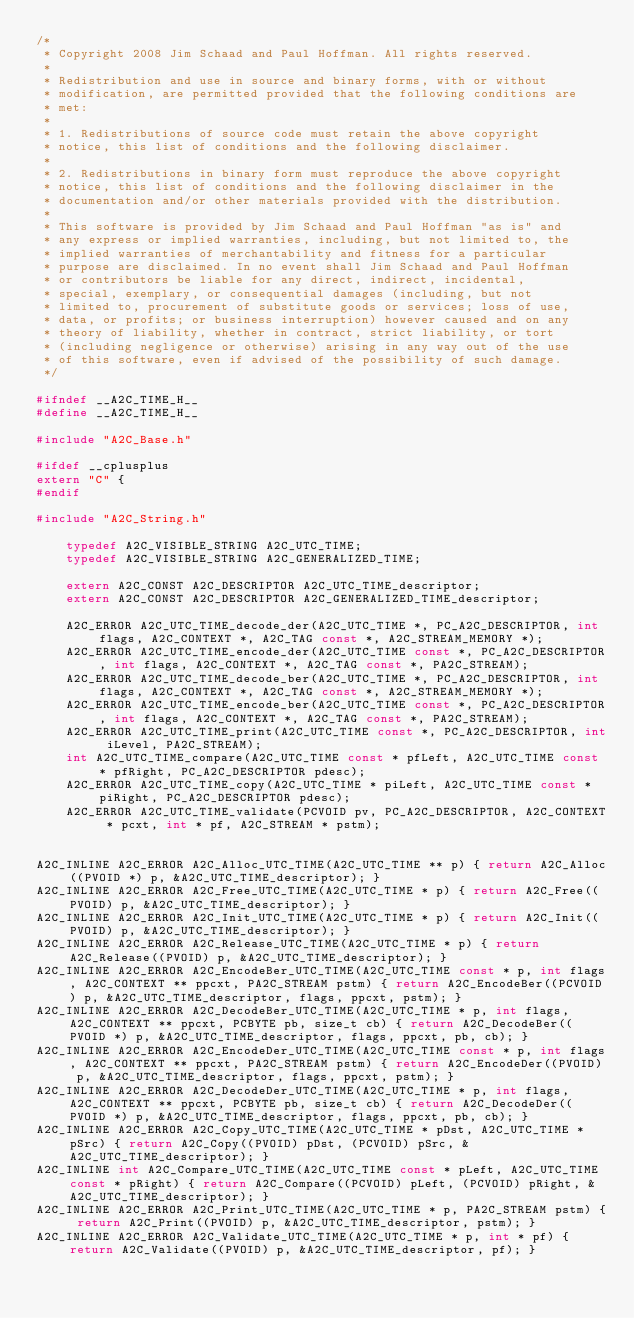<code> <loc_0><loc_0><loc_500><loc_500><_C_>/* 
 * Copyright 2008 Jim Schaad and Paul Hoffman. All rights reserved.
 * 
 * Redistribution and use in source and binary forms, with or without
 * modification, are permitted provided that the following conditions are
 * met:
 * 
 * 1. Redistributions of source code must retain the above copyright
 * notice, this list of conditions and the following disclaimer.
 * 
 * 2. Redistributions in binary form must reproduce the above copyright
 * notice, this list of conditions and the following disclaimer in the
 * documentation and/or other materials provided with the distribution.
 * 
 * This software is provided by Jim Schaad and Paul Hoffman "as is" and
 * any express or implied warranties, including, but not limited to, the
 * implied warranties of merchantability and fitness for a particular
 * purpose are disclaimed. In no event shall Jim Schaad and Paul Hoffman
 * or contributors be liable for any direct, indirect, incidental,
 * special, exemplary, or consequential damages (including, but not
 * limited to, procurement of substitute goods or services; loss of use,
 * data, or profits; or business interruption) however caused and on any
 * theory of liability, whether in contract, strict liability, or tort
 * (including negligence or otherwise) arising in any way out of the use
 * of this software, even if advised of the possibility of such damage.
 */

#ifndef __A2C_TIME_H__
#define __A2C_TIME_H__

#include "A2C_Base.h"

#ifdef __cplusplus
extern "C" {
#endif

#include "A2C_String.h"
    
    typedef A2C_VISIBLE_STRING A2C_UTC_TIME;
    typedef A2C_VISIBLE_STRING A2C_GENERALIZED_TIME;

    extern A2C_CONST A2C_DESCRIPTOR A2C_UTC_TIME_descriptor;
    extern A2C_CONST A2C_DESCRIPTOR A2C_GENERALIZED_TIME_descriptor;

    A2C_ERROR A2C_UTC_TIME_decode_der(A2C_UTC_TIME *, PC_A2C_DESCRIPTOR, int flags, A2C_CONTEXT *, A2C_TAG const *, A2C_STREAM_MEMORY *);
    A2C_ERROR A2C_UTC_TIME_encode_der(A2C_UTC_TIME const *, PC_A2C_DESCRIPTOR, int flags, A2C_CONTEXT *, A2C_TAG const *, PA2C_STREAM);
    A2C_ERROR A2C_UTC_TIME_decode_ber(A2C_UTC_TIME *, PC_A2C_DESCRIPTOR, int flags, A2C_CONTEXT *, A2C_TAG const *, A2C_STREAM_MEMORY *);
    A2C_ERROR A2C_UTC_TIME_encode_ber(A2C_UTC_TIME const *, PC_A2C_DESCRIPTOR, int flags, A2C_CONTEXT *, A2C_TAG const *, PA2C_STREAM);
    A2C_ERROR A2C_UTC_TIME_print(A2C_UTC_TIME const *, PC_A2C_DESCRIPTOR, int iLevel, PA2C_STREAM);
    int A2C_UTC_TIME_compare(A2C_UTC_TIME const * pfLeft, A2C_UTC_TIME const * pfRight, PC_A2C_DESCRIPTOR pdesc);
    A2C_ERROR A2C_UTC_TIME_copy(A2C_UTC_TIME * piLeft, A2C_UTC_TIME const * piRight, PC_A2C_DESCRIPTOR pdesc);
    A2C_ERROR A2C_UTC_TIME_validate(PCVOID pv, PC_A2C_DESCRIPTOR, A2C_CONTEXT * pcxt, int * pf, A2C_STREAM * pstm);


A2C_INLINE A2C_ERROR A2C_Alloc_UTC_TIME(A2C_UTC_TIME ** p) { return A2C_Alloc((PVOID *) p, &A2C_UTC_TIME_descriptor); } 
A2C_INLINE A2C_ERROR A2C_Free_UTC_TIME(A2C_UTC_TIME * p) { return A2C_Free((PVOID) p, &A2C_UTC_TIME_descriptor); } 
A2C_INLINE A2C_ERROR A2C_Init_UTC_TIME(A2C_UTC_TIME * p) { return A2C_Init((PVOID) p, &A2C_UTC_TIME_descriptor); } 
A2C_INLINE A2C_ERROR A2C_Release_UTC_TIME(A2C_UTC_TIME * p) { return A2C_Release((PVOID) p, &A2C_UTC_TIME_descriptor); } 
A2C_INLINE A2C_ERROR A2C_EncodeBer_UTC_TIME(A2C_UTC_TIME const * p, int flags, A2C_CONTEXT ** ppcxt, PA2C_STREAM pstm) { return A2C_EncodeBer((PCVOID) p, &A2C_UTC_TIME_descriptor, flags, ppcxt, pstm); } 
A2C_INLINE A2C_ERROR A2C_DecodeBer_UTC_TIME(A2C_UTC_TIME * p, int flags, A2C_CONTEXT ** ppcxt, PCBYTE pb, size_t cb) { return A2C_DecodeBer((PVOID *) p, &A2C_UTC_TIME_descriptor, flags, ppcxt, pb, cb); } 
A2C_INLINE A2C_ERROR A2C_EncodeDer_UTC_TIME(A2C_UTC_TIME const * p, int flags, A2C_CONTEXT ** ppcxt, PA2C_STREAM pstm) { return A2C_EncodeDer((PVOID) p, &A2C_UTC_TIME_descriptor, flags, ppcxt, pstm); } 
A2C_INLINE A2C_ERROR A2C_DecodeDer_UTC_TIME(A2C_UTC_TIME * p, int flags, A2C_CONTEXT ** ppcxt, PCBYTE pb, size_t cb) { return A2C_DecodeDer((PVOID *) p, &A2C_UTC_TIME_descriptor, flags, ppcxt, pb, cb); } 
A2C_INLINE A2C_ERROR A2C_Copy_UTC_TIME(A2C_UTC_TIME * pDst, A2C_UTC_TIME * pSrc) { return A2C_Copy((PVOID) pDst, (PCVOID) pSrc, &A2C_UTC_TIME_descriptor); } 
A2C_INLINE int A2C_Compare_UTC_TIME(A2C_UTC_TIME const * pLeft, A2C_UTC_TIME const * pRight) { return A2C_Compare((PCVOID) pLeft, (PCVOID) pRight, &A2C_UTC_TIME_descriptor); } 
A2C_INLINE A2C_ERROR A2C_Print_UTC_TIME(A2C_UTC_TIME * p, PA2C_STREAM pstm) { return A2C_Print((PVOID) p, &A2C_UTC_TIME_descriptor, pstm); } 
A2C_INLINE A2C_ERROR A2C_Validate_UTC_TIME(A2C_UTC_TIME * p, int * pf) { return A2C_Validate((PVOID) p, &A2C_UTC_TIME_descriptor, pf); } </code> 